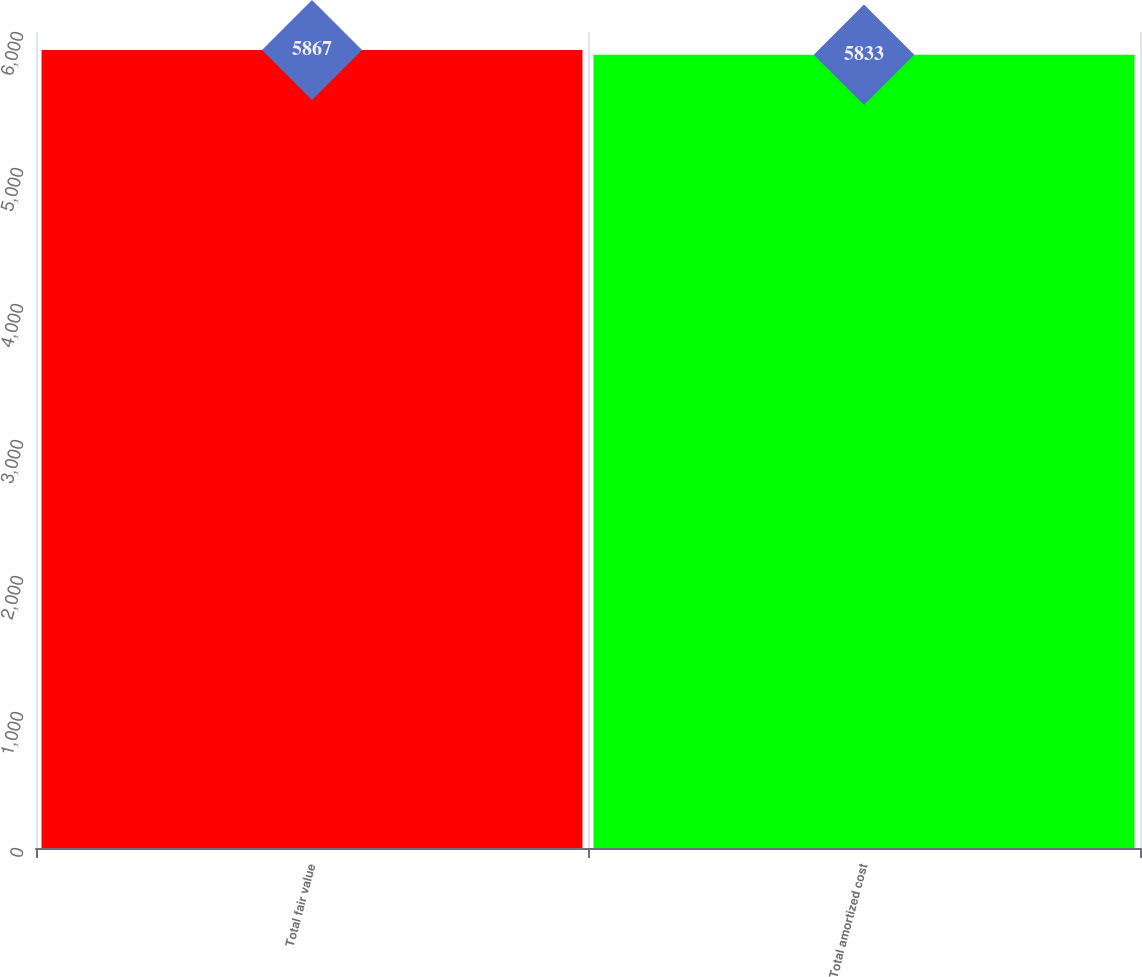<chart> <loc_0><loc_0><loc_500><loc_500><bar_chart><fcel>Total fair value<fcel>Total amortized cost<nl><fcel>5867<fcel>5833<nl></chart> 